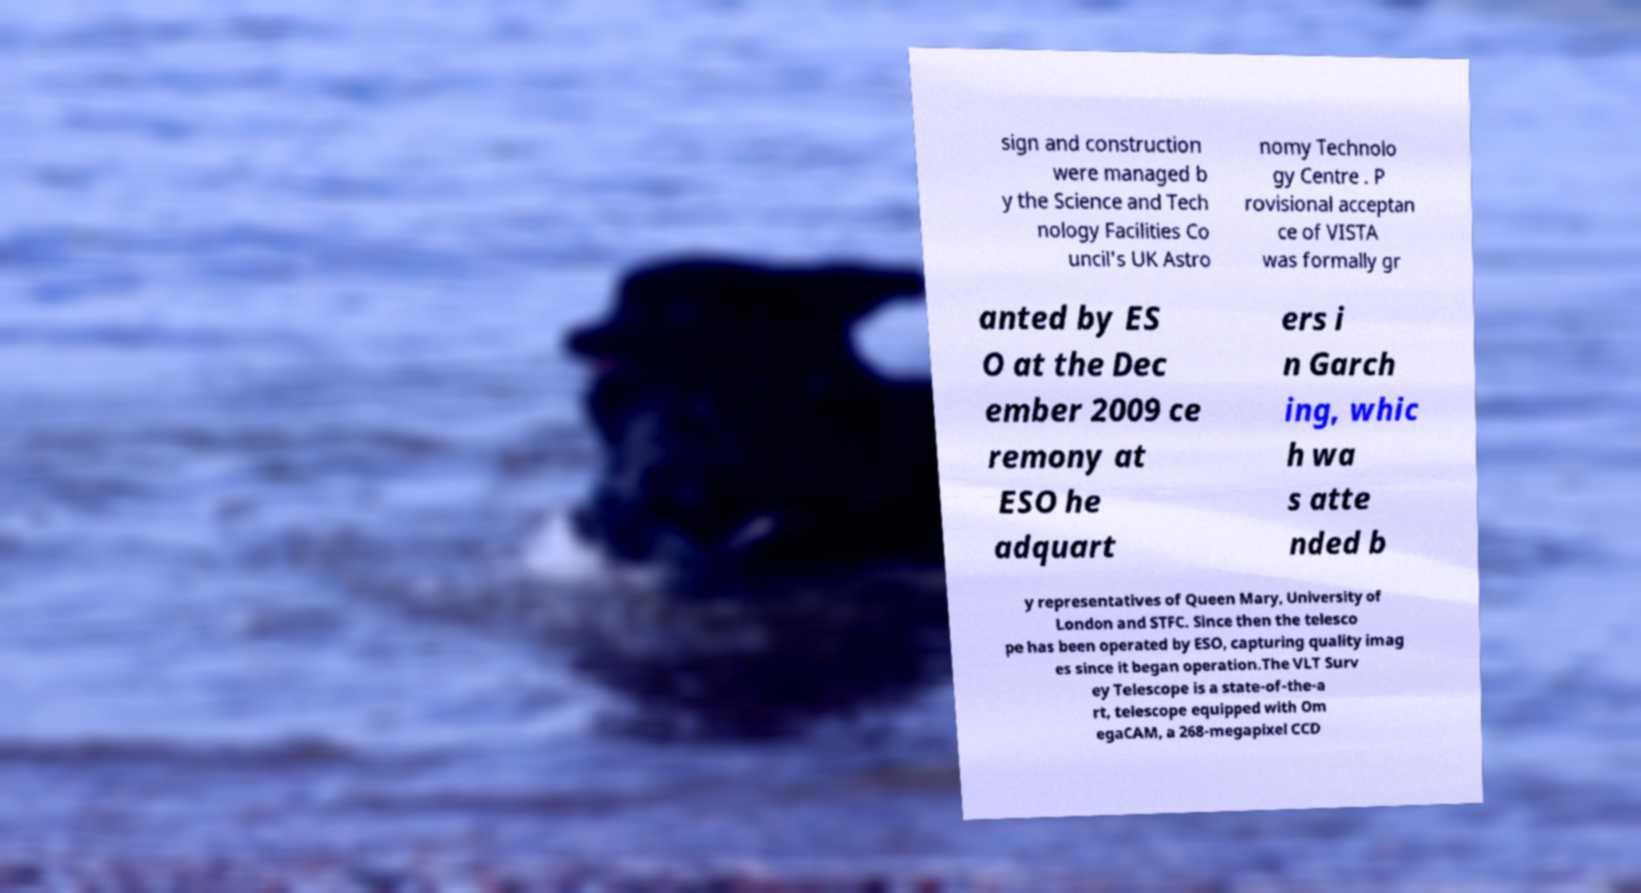Please read and relay the text visible in this image. What does it say? sign and construction were managed b y the Science and Tech nology Facilities Co uncil's UK Astro nomy Technolo gy Centre . P rovisional acceptan ce of VISTA was formally gr anted by ES O at the Dec ember 2009 ce remony at ESO he adquart ers i n Garch ing, whic h wa s atte nded b y representatives of Queen Mary, University of London and STFC. Since then the telesco pe has been operated by ESO, capturing quality imag es since it began operation.The VLT Surv ey Telescope is a state-of-the-a rt, telescope equipped with Om egaCAM, a 268-megapixel CCD 